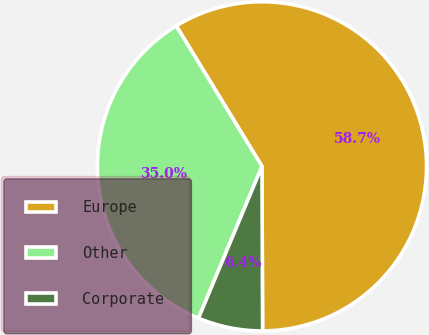<chart> <loc_0><loc_0><loc_500><loc_500><pie_chart><fcel>Europe<fcel>Other<fcel>Corporate<nl><fcel>58.66%<fcel>34.98%<fcel>6.36%<nl></chart> 